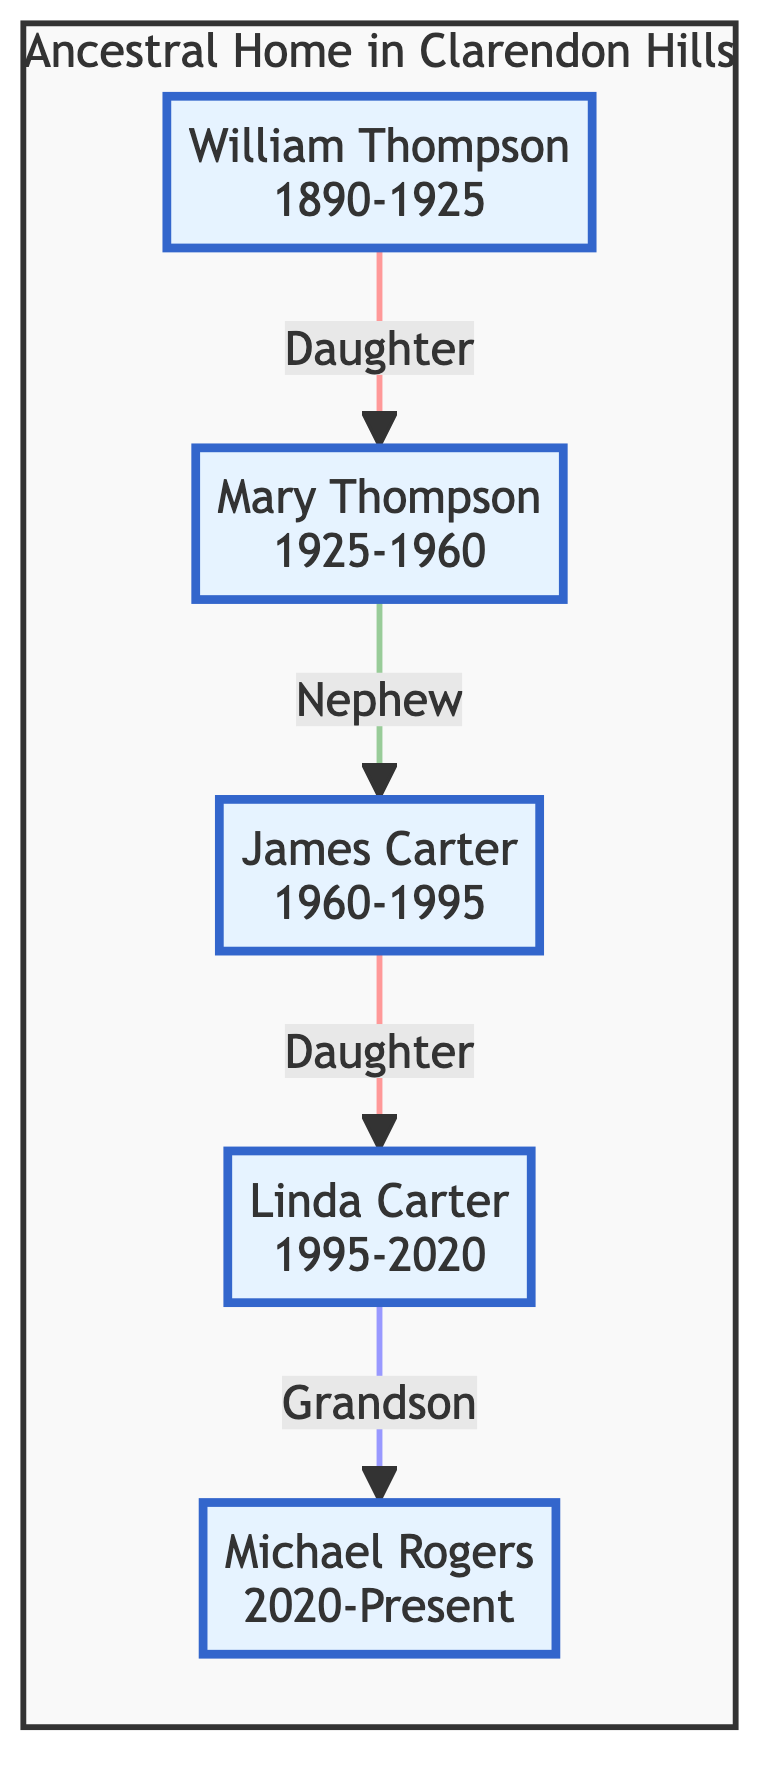What year did William Thompson purchase the house? The first purchase is noted in the diagram associated with William Thompson, which states the year is 1890.
Answer: 1890 What relationship did Mary Thompson have to William Thompson? The diagram indicates that Mary Thompson is the daughter of William Thompson.
Answer: Daughter Who owned the house before Michael Rogers? The diagram shows arrows leading to Michael Rogers from Linda Carter, indicating that Linda Carter owned the house prior to him.
Answer: Linda Carter What is the transition type of ownership from James Carter to Linda Carter? By examining the connection between James Carter and Linda Carter in the diagram, it is labeled as inheritance.
Answer: Inheritance How many individuals have owned the ancestral home? Counting the nodes in the diagram, there are five different individuals listed as homeowners.
Answer: Five What major change did Mary Thompson make in 1925? The historical note linked to Mary Thompson's ownership in the diagram specifies that she added a sunroom to the house.
Answer: Added a sunroom What was the purchase price when James Carter acquired the house? The diagram details that James Carter purchased the house for $5000, making this the purchase price listed in his section.
Answer: 5000 Which family member created a digital archive of the home's history? The diagram indicates that Michael Rogers, the grandson, is responsible for creating a digital archive of the home's history and family records.
Answer: Michael Rogers What significant action did Linda Carter take related to the home's structure? The historical note pertaining to Linda Carter's ownership states that she preserved the Victorian architecture while modernizing the interiors, which highlights her contribution to the house.
Answer: Preserved Victorian architecture What relationship does James Carter have to Mary Thompson? The connection between Mary Thompson and James Carter in the diagram defines James as the nephew of Mary Thompson.
Answer: Nephew 